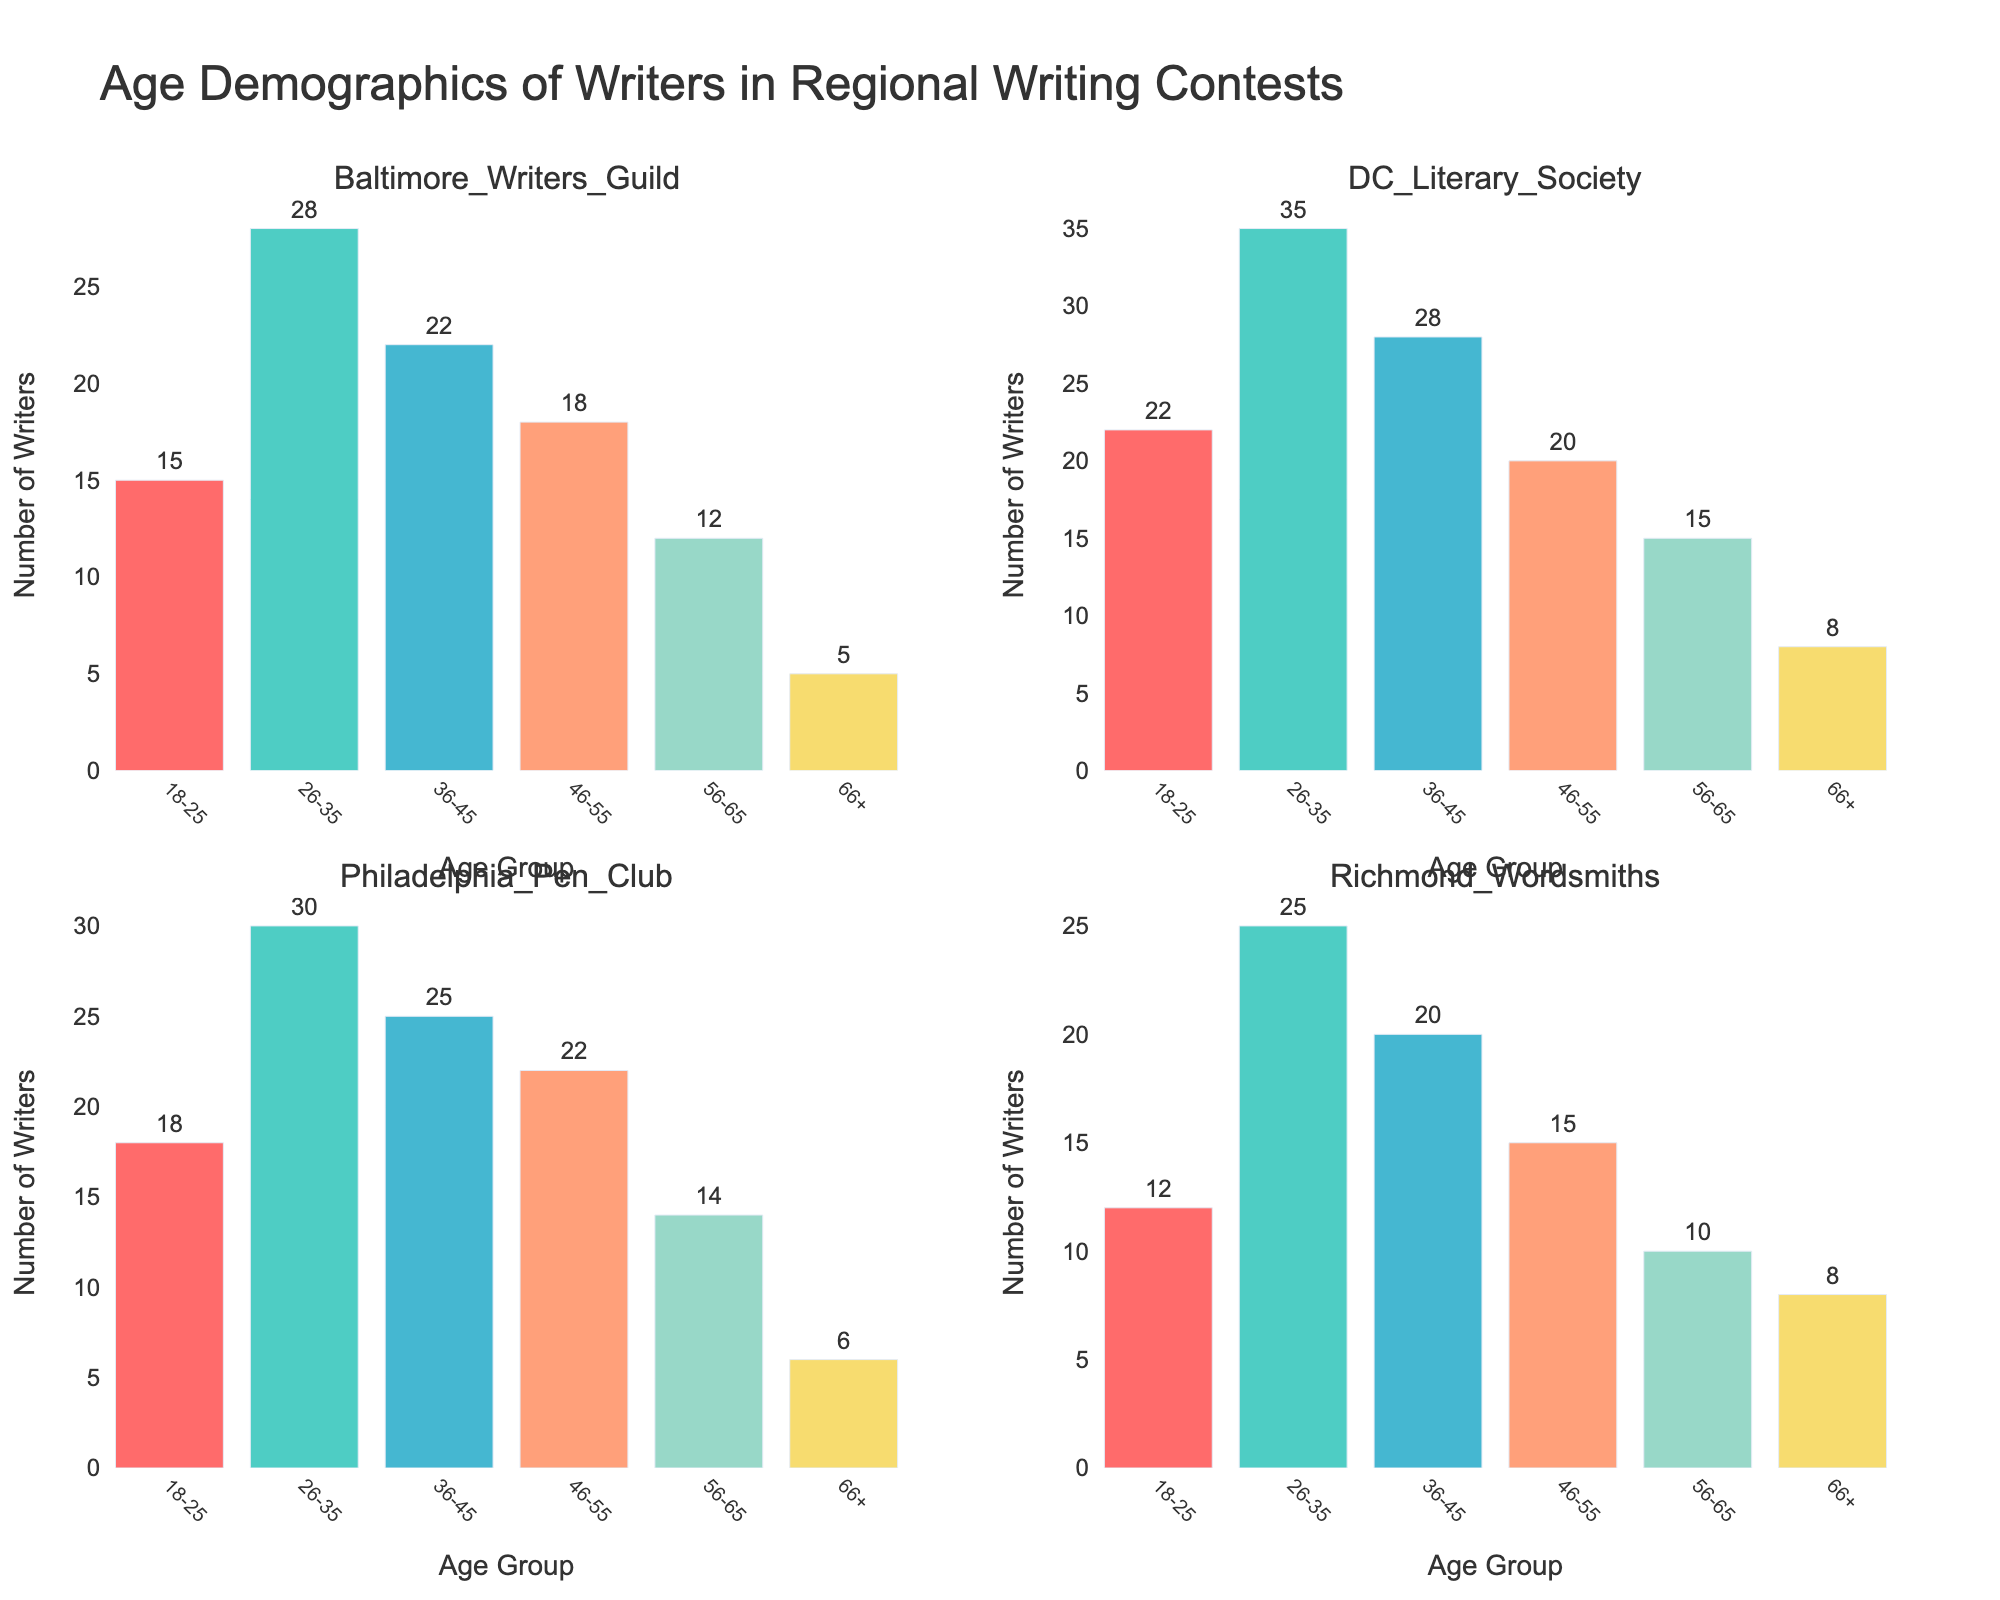What is the title of the figure? The title is usually placed at the top of the figure to give an overview of what the chart represents.
Answer: Age Demographics of Writers in Regional Writing Contests What age group has the highest number of participants in the DC Literary Society? By examining the bar heights in the subplot for DC Literary Society, the highest bar corresponds with the 26-35 age group.
Answer: 26-35 Which contest has the least number of writers in the 18-25 age group? By comparing the bars in the 18-25 row across all subplots, Richmond Wordsmiths has the smallest bar.
Answer: Richmond Wordsmiths How many writers aged 46-55 participated in the Baltimore Writers Guild and Philadelphia Pen Club combined? Sum the values for the 46-55 age group in both Baltimore Writers Guild and Philadelphia Pen Club (18 + 22).
Answer: 40 Is the number of participants in the 66+ age group greater than those in the 56-65 age group for the Richmond Wordsmiths? Compare the bar heights for the age groups 66+ (8) and 56-65 (10) in the Richmond Wordsmiths subplot; 66+ is less.
Answer: No Which age group has the smallest representation across all four contests? Look at the individual subplots, the 66+ category has the shortest bars overall.
Answer: 66+ What is the average number of writers aged 26-35 across all contests? Calculate the sum of the 26-35 groups (28 + 35 + 30 + 25) and divide by the number of contests (4). (Sum = 118, divide by 4).
Answer: 29.5 What is the total number of writers in the 36-45 age group across all four contests? Add the numbers for the 36-45 age group from each subplot (22 + 28 + 25 + 20).
Answer: 95 In which contest is the participation gap between the 26-35 and 46-55 age groups the largest? Compute the difference between the two age groups for each contest: 26-35 and 46-55 (Baltimore: 10, DC: 15, Philly: 8, Richmond: 10).
Answer: DC Literary Society Are participants in the 18-25 and 46-55 age groups in the Philadelphia Pen Club almost equal in number? Compare the number of participants in the 18-25 (18) and 46-55 (22) age groups. The difference is not significant.
Answer: No 